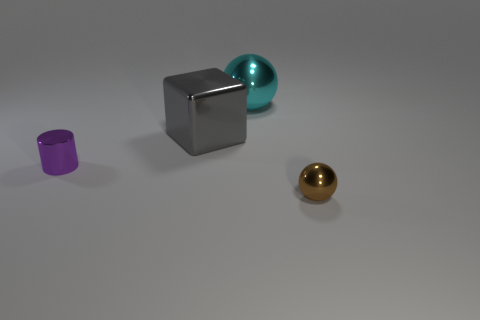What number of shiny objects are to the left of the small metal thing that is on the right side of the large cyan metal thing?
Offer a terse response. 3. How many cylinders are either purple metal things or gray metallic things?
Your response must be concise. 1. There is a object that is both in front of the big gray shiny block and to the left of the brown metallic ball; what is its color?
Make the answer very short. Purple. Are there any other things that have the same color as the tiny shiny sphere?
Your answer should be very brief. No. There is a sphere that is in front of the tiny thing left of the gray object; what color is it?
Keep it short and to the point. Brown. Is the size of the purple cylinder the same as the cube?
Offer a very short reply. No. Is the small thing that is to the right of the cyan metal sphere made of the same material as the ball behind the purple metallic object?
Provide a succinct answer. Yes. There is a large object behind the gray metallic object behind the tiny metallic thing that is left of the large cyan thing; what is its shape?
Give a very brief answer. Sphere. Are there more cyan rubber spheres than shiny cylinders?
Your answer should be compact. No. Are there any small metal cylinders?
Offer a terse response. Yes. 